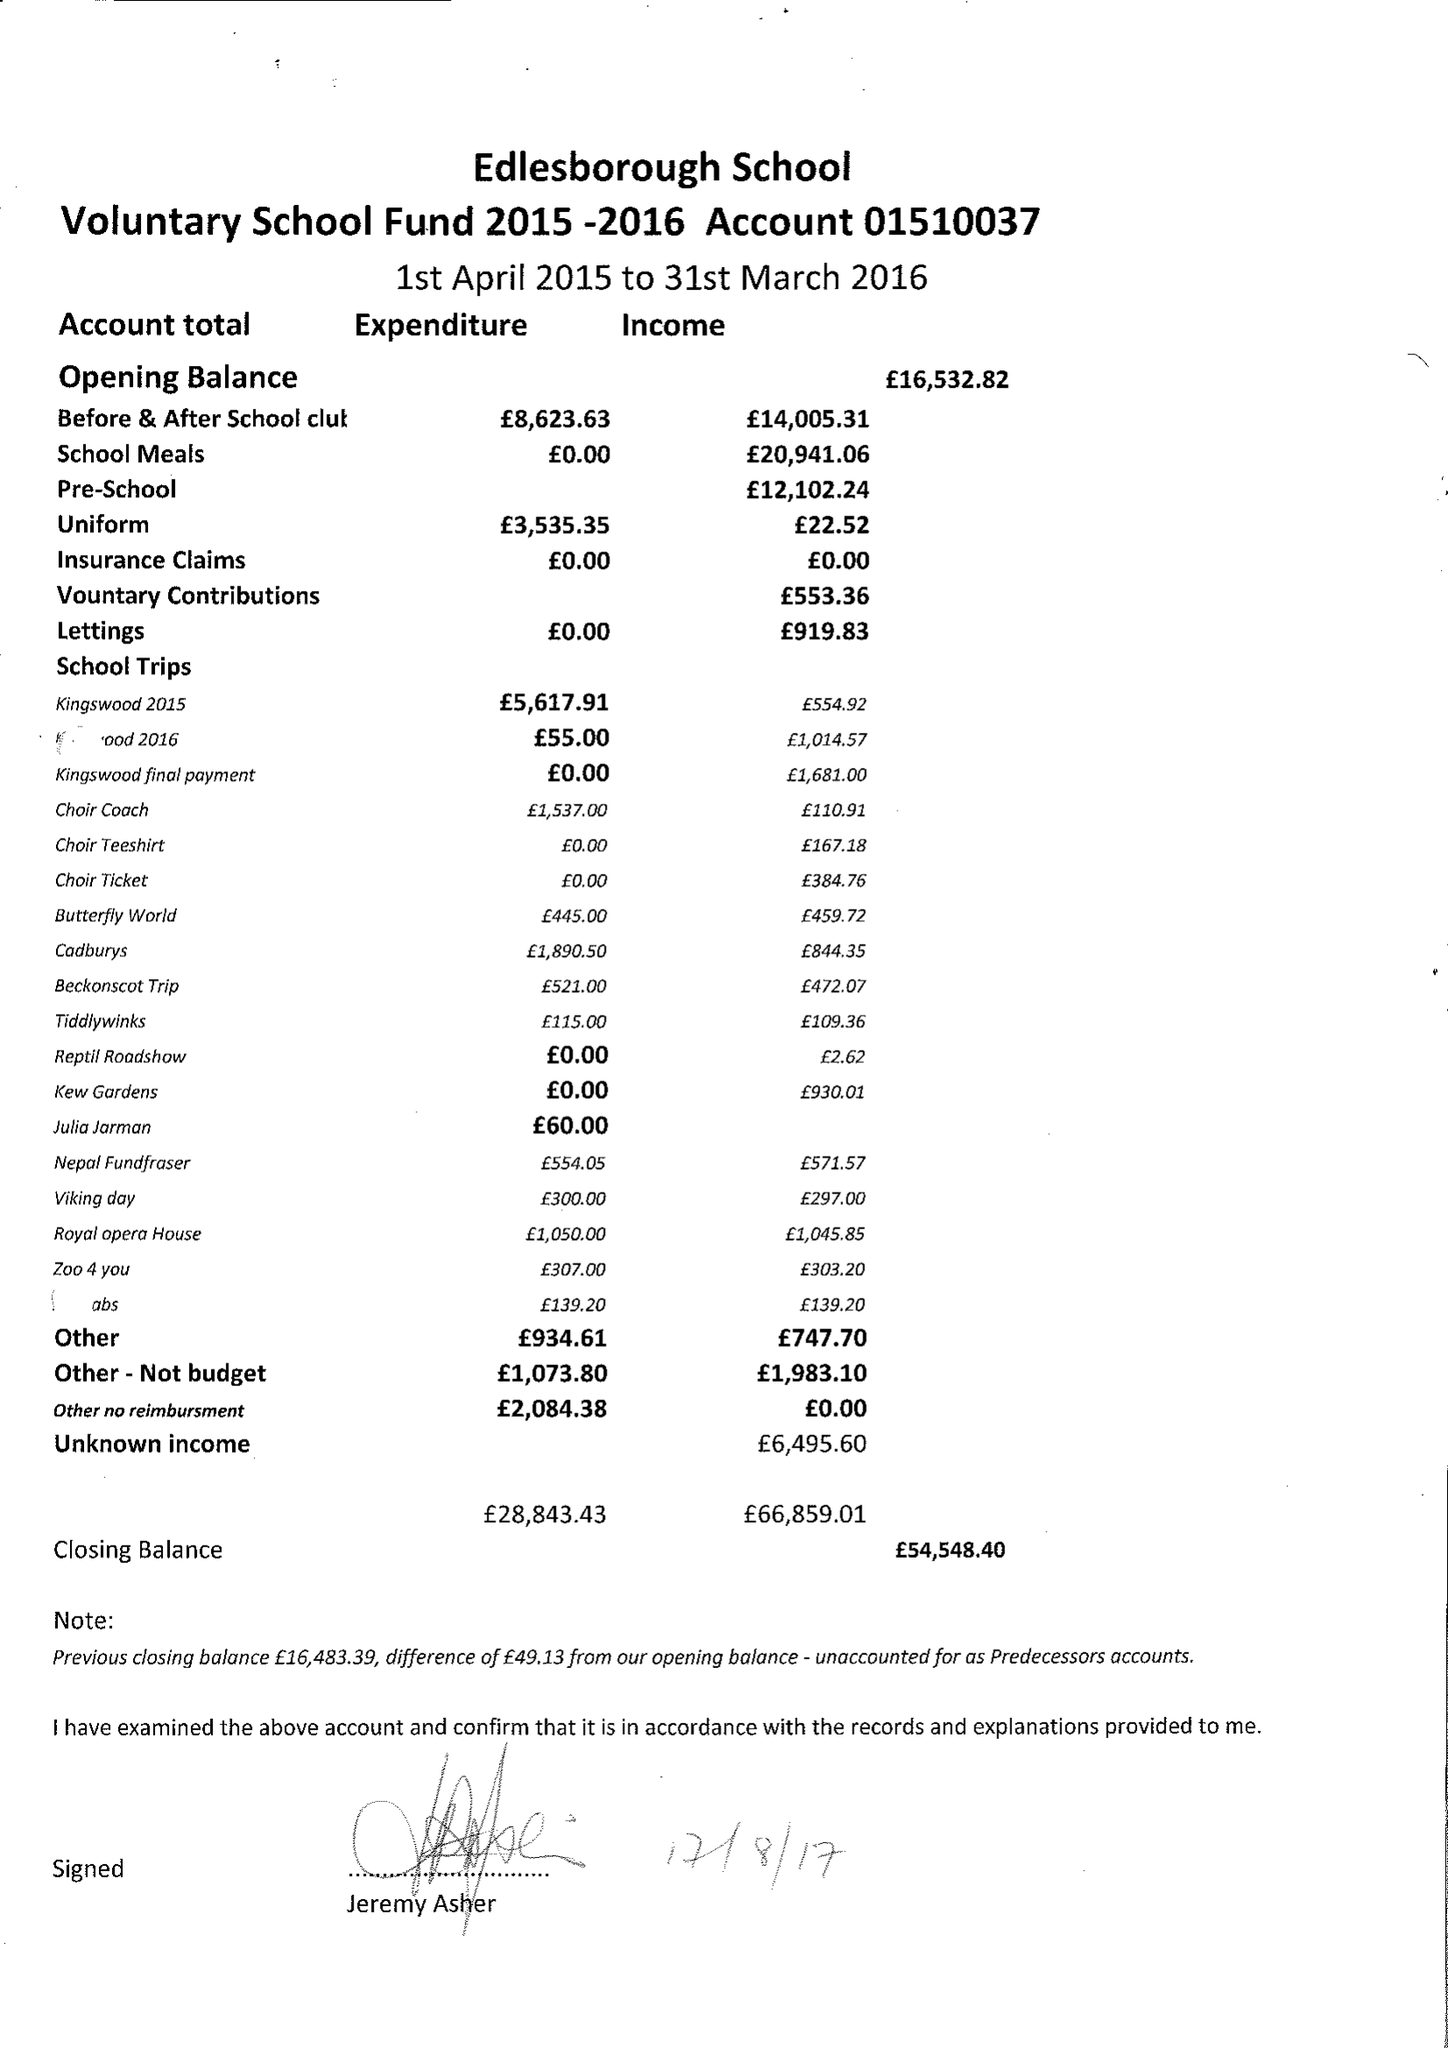What is the value for the address__street_line?
Answer the question using a single word or phrase. HIGH STREET 